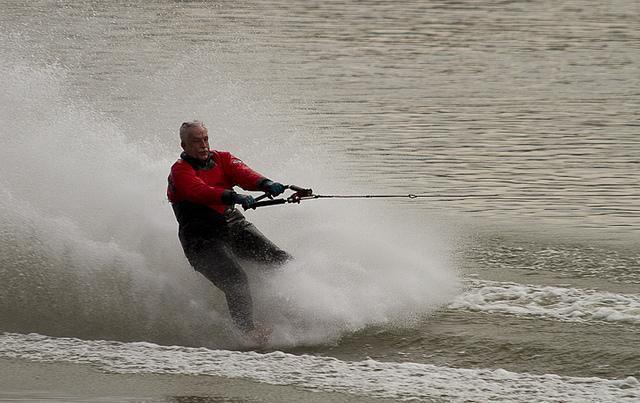How many tracks have trains on them?
Give a very brief answer. 0. 